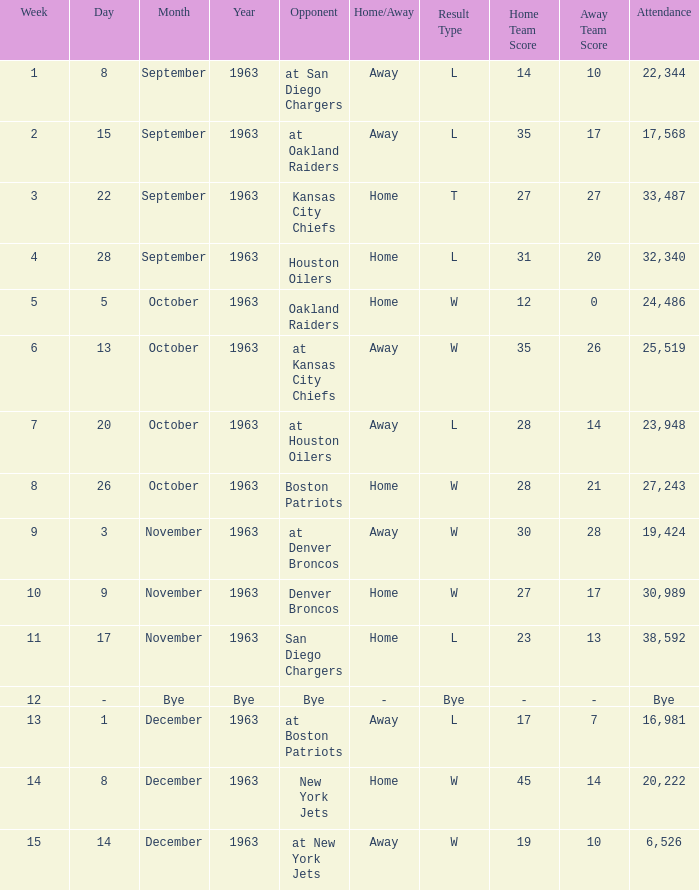Which Result has a Week smaller than 11, and Attendance of 17,568? L 35–17. 